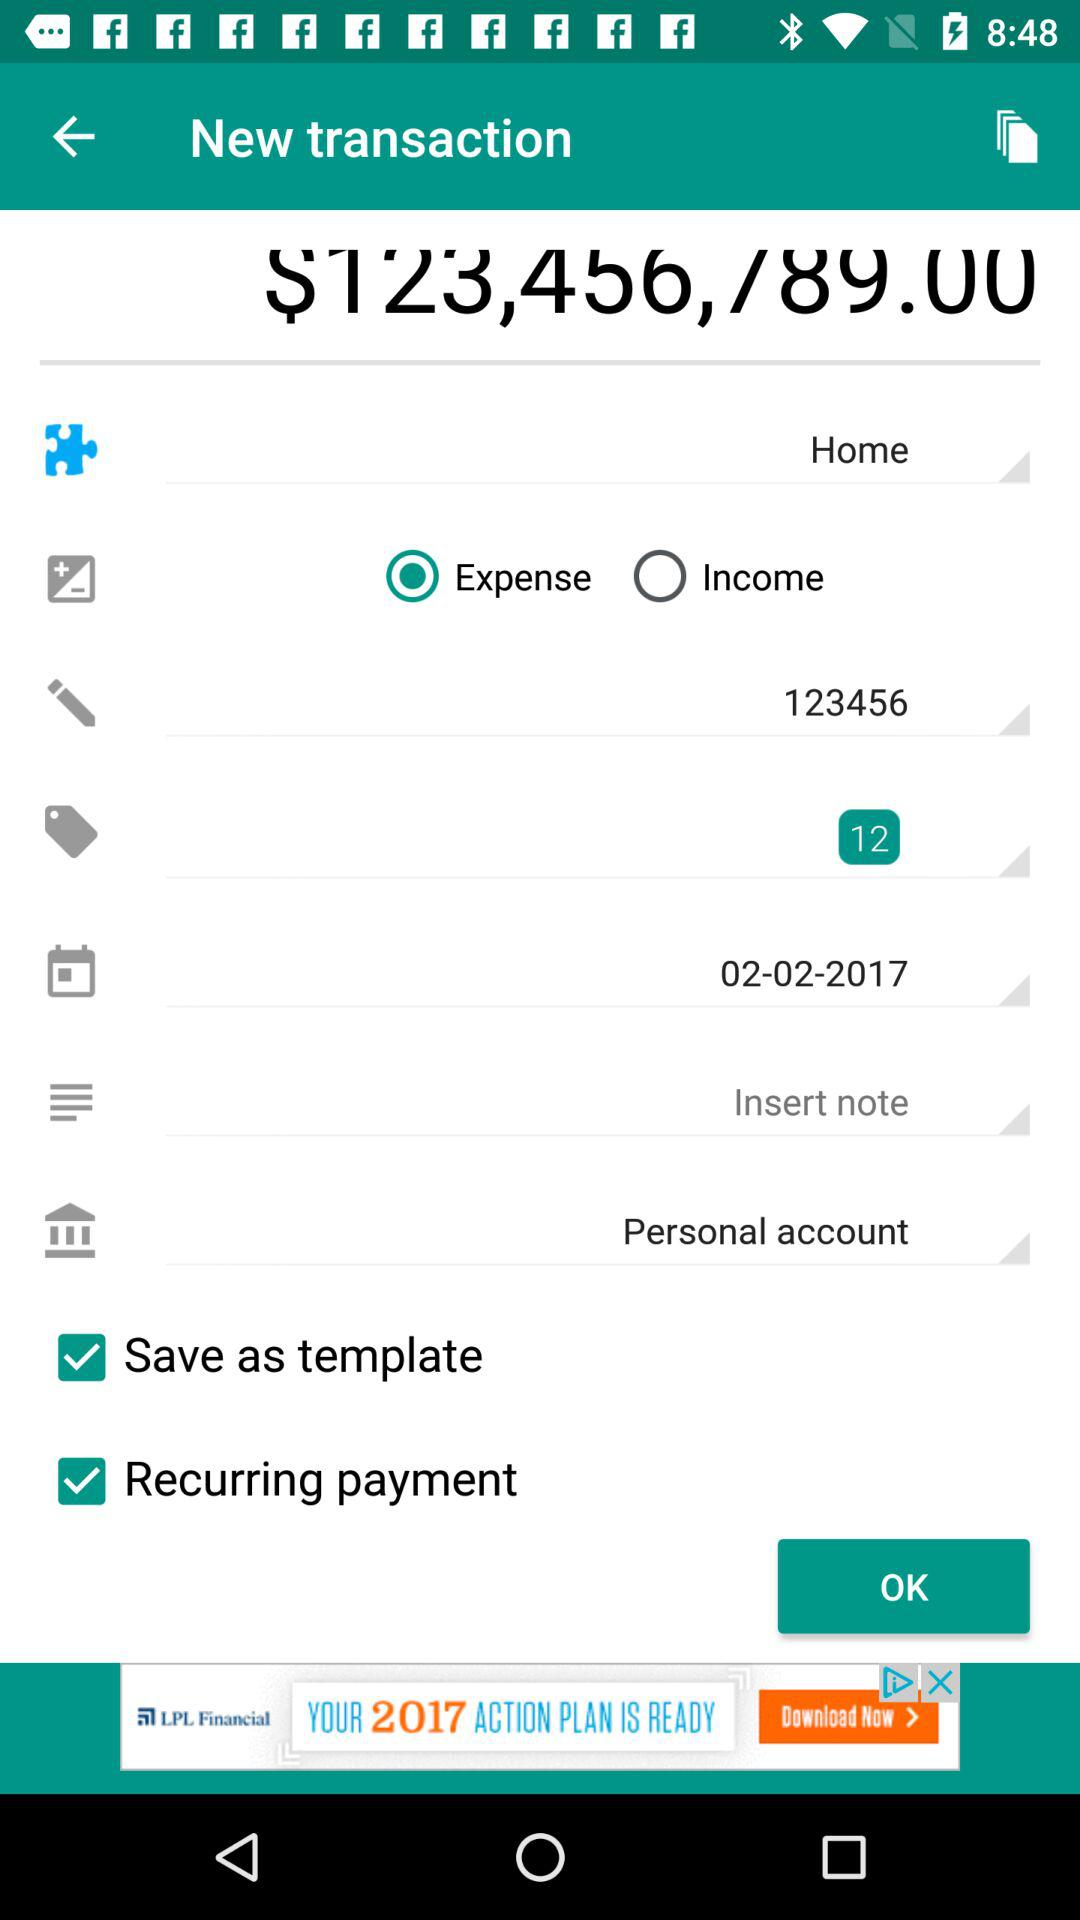What type of transaction is selected in the screenshot? The type of transaction selected in the screenshot is "Expense". 